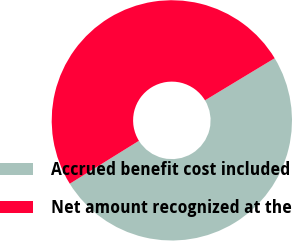Convert chart to OTSL. <chart><loc_0><loc_0><loc_500><loc_500><pie_chart><fcel>Accrued benefit cost included<fcel>Net amount recognized at the<nl><fcel>49.81%<fcel>50.19%<nl></chart> 